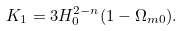Convert formula to latex. <formula><loc_0><loc_0><loc_500><loc_500>K _ { 1 } = 3 H _ { 0 } ^ { 2 - n } ( 1 - \Omega _ { m 0 } ) .</formula> 